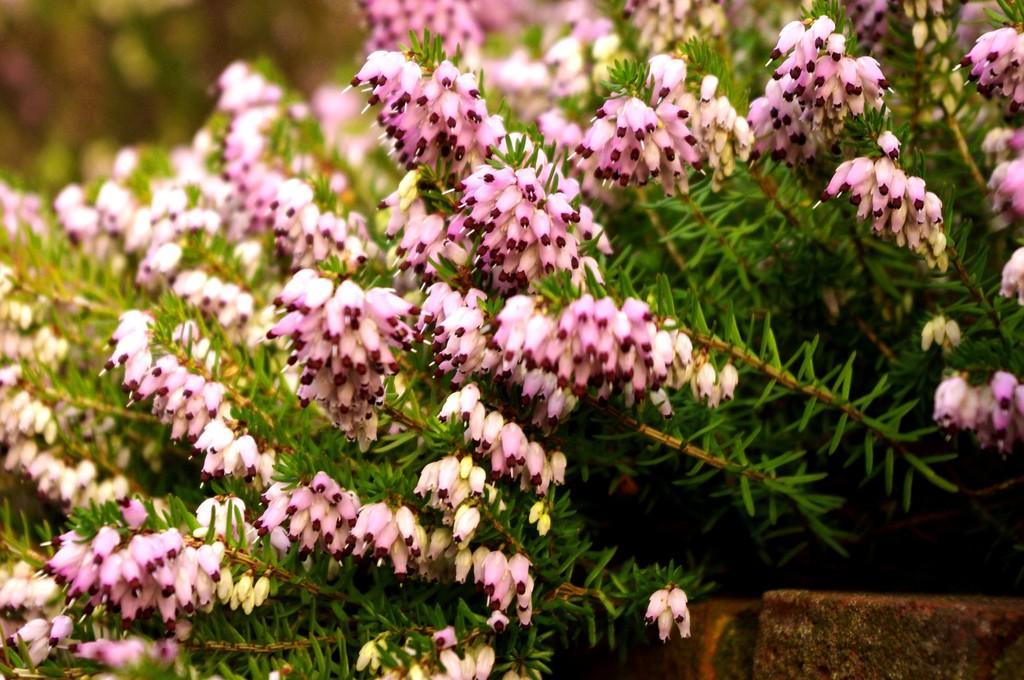Can you describe this image briefly? In this picture there are light pink and yellow color flowers on the plants. At the back the image is blurry. At the bottom right there is a wall. 